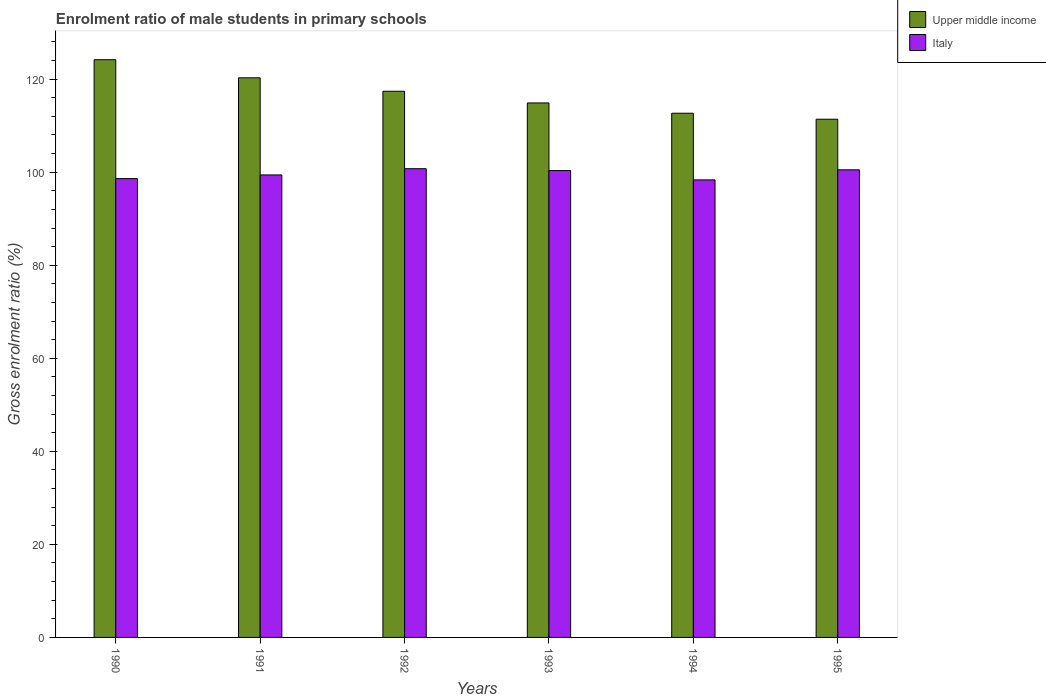How many different coloured bars are there?
Your answer should be very brief. 2. Are the number of bars on each tick of the X-axis equal?
Provide a succinct answer. Yes. How many bars are there on the 6th tick from the left?
Give a very brief answer. 2. What is the enrolment ratio of male students in primary schools in Italy in 1993?
Provide a short and direct response. 100.34. Across all years, what is the maximum enrolment ratio of male students in primary schools in Upper middle income?
Make the answer very short. 124.17. Across all years, what is the minimum enrolment ratio of male students in primary schools in Italy?
Keep it short and to the point. 98.34. In which year was the enrolment ratio of male students in primary schools in Upper middle income maximum?
Ensure brevity in your answer.  1990. What is the total enrolment ratio of male students in primary schools in Italy in the graph?
Provide a short and direct response. 597.97. What is the difference between the enrolment ratio of male students in primary schools in Upper middle income in 1993 and that in 1995?
Offer a very short reply. 3.5. What is the difference between the enrolment ratio of male students in primary schools in Italy in 1992 and the enrolment ratio of male students in primary schools in Upper middle income in 1991?
Your response must be concise. -19.53. What is the average enrolment ratio of male students in primary schools in Italy per year?
Give a very brief answer. 99.66. In the year 1992, what is the difference between the enrolment ratio of male students in primary schools in Italy and enrolment ratio of male students in primary schools in Upper middle income?
Provide a succinct answer. -16.65. In how many years, is the enrolment ratio of male students in primary schools in Upper middle income greater than 120 %?
Your answer should be compact. 2. What is the ratio of the enrolment ratio of male students in primary schools in Upper middle income in 1991 to that in 1994?
Make the answer very short. 1.07. What is the difference between the highest and the second highest enrolment ratio of male students in primary schools in Italy?
Keep it short and to the point. 0.24. What is the difference between the highest and the lowest enrolment ratio of male students in primary schools in Upper middle income?
Make the answer very short. 12.79. In how many years, is the enrolment ratio of male students in primary schools in Upper middle income greater than the average enrolment ratio of male students in primary schools in Upper middle income taken over all years?
Your answer should be very brief. 3. What does the 1st bar from the left in 1995 represents?
Provide a succinct answer. Upper middle income. How many bars are there?
Keep it short and to the point. 12. Are all the bars in the graph horizontal?
Provide a succinct answer. No. How many years are there in the graph?
Provide a short and direct response. 6. What is the difference between two consecutive major ticks on the Y-axis?
Provide a succinct answer. 20. Where does the legend appear in the graph?
Keep it short and to the point. Top right. How are the legend labels stacked?
Provide a short and direct response. Vertical. What is the title of the graph?
Ensure brevity in your answer.  Enrolment ratio of male students in primary schools. Does "Morocco" appear as one of the legend labels in the graph?
Provide a short and direct response. No. What is the label or title of the Y-axis?
Provide a short and direct response. Gross enrolment ratio (%). What is the Gross enrolment ratio (%) in Upper middle income in 1990?
Make the answer very short. 124.17. What is the Gross enrolment ratio (%) of Italy in 1990?
Provide a short and direct response. 98.62. What is the Gross enrolment ratio (%) in Upper middle income in 1991?
Give a very brief answer. 120.28. What is the Gross enrolment ratio (%) of Italy in 1991?
Your answer should be compact. 99.41. What is the Gross enrolment ratio (%) of Upper middle income in 1992?
Your answer should be compact. 117.4. What is the Gross enrolment ratio (%) in Italy in 1992?
Provide a short and direct response. 100.75. What is the Gross enrolment ratio (%) in Upper middle income in 1993?
Give a very brief answer. 114.88. What is the Gross enrolment ratio (%) in Italy in 1993?
Make the answer very short. 100.34. What is the Gross enrolment ratio (%) in Upper middle income in 1994?
Make the answer very short. 112.67. What is the Gross enrolment ratio (%) of Italy in 1994?
Keep it short and to the point. 98.34. What is the Gross enrolment ratio (%) of Upper middle income in 1995?
Your answer should be very brief. 111.38. What is the Gross enrolment ratio (%) in Italy in 1995?
Offer a terse response. 100.51. Across all years, what is the maximum Gross enrolment ratio (%) in Upper middle income?
Offer a very short reply. 124.17. Across all years, what is the maximum Gross enrolment ratio (%) in Italy?
Give a very brief answer. 100.75. Across all years, what is the minimum Gross enrolment ratio (%) in Upper middle income?
Your answer should be compact. 111.38. Across all years, what is the minimum Gross enrolment ratio (%) in Italy?
Your response must be concise. 98.34. What is the total Gross enrolment ratio (%) of Upper middle income in the graph?
Your response must be concise. 700.78. What is the total Gross enrolment ratio (%) of Italy in the graph?
Your answer should be very brief. 597.97. What is the difference between the Gross enrolment ratio (%) of Upper middle income in 1990 and that in 1991?
Your answer should be compact. 3.89. What is the difference between the Gross enrolment ratio (%) in Italy in 1990 and that in 1991?
Provide a succinct answer. -0.79. What is the difference between the Gross enrolment ratio (%) of Upper middle income in 1990 and that in 1992?
Your response must be concise. 6.78. What is the difference between the Gross enrolment ratio (%) in Italy in 1990 and that in 1992?
Offer a very short reply. -2.13. What is the difference between the Gross enrolment ratio (%) of Upper middle income in 1990 and that in 1993?
Offer a very short reply. 9.29. What is the difference between the Gross enrolment ratio (%) in Italy in 1990 and that in 1993?
Provide a succinct answer. -1.72. What is the difference between the Gross enrolment ratio (%) in Upper middle income in 1990 and that in 1994?
Make the answer very short. 11.5. What is the difference between the Gross enrolment ratio (%) in Italy in 1990 and that in 1994?
Your response must be concise. 0.28. What is the difference between the Gross enrolment ratio (%) of Upper middle income in 1990 and that in 1995?
Offer a terse response. 12.79. What is the difference between the Gross enrolment ratio (%) of Italy in 1990 and that in 1995?
Your response must be concise. -1.89. What is the difference between the Gross enrolment ratio (%) in Upper middle income in 1991 and that in 1992?
Keep it short and to the point. 2.88. What is the difference between the Gross enrolment ratio (%) of Italy in 1991 and that in 1992?
Your answer should be very brief. -1.34. What is the difference between the Gross enrolment ratio (%) in Upper middle income in 1991 and that in 1993?
Your response must be concise. 5.4. What is the difference between the Gross enrolment ratio (%) in Italy in 1991 and that in 1993?
Make the answer very short. -0.94. What is the difference between the Gross enrolment ratio (%) of Upper middle income in 1991 and that in 1994?
Provide a succinct answer. 7.61. What is the difference between the Gross enrolment ratio (%) of Italy in 1991 and that in 1994?
Provide a short and direct response. 1.07. What is the difference between the Gross enrolment ratio (%) of Upper middle income in 1991 and that in 1995?
Give a very brief answer. 8.9. What is the difference between the Gross enrolment ratio (%) in Italy in 1991 and that in 1995?
Provide a succinct answer. -1.1. What is the difference between the Gross enrolment ratio (%) of Upper middle income in 1992 and that in 1993?
Ensure brevity in your answer.  2.51. What is the difference between the Gross enrolment ratio (%) in Italy in 1992 and that in 1993?
Your answer should be compact. 0.41. What is the difference between the Gross enrolment ratio (%) in Upper middle income in 1992 and that in 1994?
Make the answer very short. 4.73. What is the difference between the Gross enrolment ratio (%) in Italy in 1992 and that in 1994?
Give a very brief answer. 2.41. What is the difference between the Gross enrolment ratio (%) in Upper middle income in 1992 and that in 1995?
Make the answer very short. 6.02. What is the difference between the Gross enrolment ratio (%) in Italy in 1992 and that in 1995?
Your response must be concise. 0.24. What is the difference between the Gross enrolment ratio (%) of Upper middle income in 1993 and that in 1994?
Give a very brief answer. 2.21. What is the difference between the Gross enrolment ratio (%) of Italy in 1993 and that in 1994?
Give a very brief answer. 2. What is the difference between the Gross enrolment ratio (%) of Upper middle income in 1993 and that in 1995?
Provide a short and direct response. 3.5. What is the difference between the Gross enrolment ratio (%) in Italy in 1993 and that in 1995?
Ensure brevity in your answer.  -0.16. What is the difference between the Gross enrolment ratio (%) of Upper middle income in 1994 and that in 1995?
Make the answer very short. 1.29. What is the difference between the Gross enrolment ratio (%) in Italy in 1994 and that in 1995?
Offer a very short reply. -2.16. What is the difference between the Gross enrolment ratio (%) of Upper middle income in 1990 and the Gross enrolment ratio (%) of Italy in 1991?
Your response must be concise. 24.76. What is the difference between the Gross enrolment ratio (%) of Upper middle income in 1990 and the Gross enrolment ratio (%) of Italy in 1992?
Offer a very short reply. 23.42. What is the difference between the Gross enrolment ratio (%) in Upper middle income in 1990 and the Gross enrolment ratio (%) in Italy in 1993?
Provide a succinct answer. 23.83. What is the difference between the Gross enrolment ratio (%) in Upper middle income in 1990 and the Gross enrolment ratio (%) in Italy in 1994?
Your answer should be compact. 25.83. What is the difference between the Gross enrolment ratio (%) of Upper middle income in 1990 and the Gross enrolment ratio (%) of Italy in 1995?
Your answer should be very brief. 23.67. What is the difference between the Gross enrolment ratio (%) of Upper middle income in 1991 and the Gross enrolment ratio (%) of Italy in 1992?
Your answer should be compact. 19.53. What is the difference between the Gross enrolment ratio (%) in Upper middle income in 1991 and the Gross enrolment ratio (%) in Italy in 1993?
Provide a succinct answer. 19.94. What is the difference between the Gross enrolment ratio (%) in Upper middle income in 1991 and the Gross enrolment ratio (%) in Italy in 1994?
Offer a terse response. 21.94. What is the difference between the Gross enrolment ratio (%) in Upper middle income in 1991 and the Gross enrolment ratio (%) in Italy in 1995?
Provide a short and direct response. 19.77. What is the difference between the Gross enrolment ratio (%) in Upper middle income in 1992 and the Gross enrolment ratio (%) in Italy in 1993?
Keep it short and to the point. 17.05. What is the difference between the Gross enrolment ratio (%) of Upper middle income in 1992 and the Gross enrolment ratio (%) of Italy in 1994?
Your answer should be compact. 19.05. What is the difference between the Gross enrolment ratio (%) in Upper middle income in 1992 and the Gross enrolment ratio (%) in Italy in 1995?
Offer a very short reply. 16.89. What is the difference between the Gross enrolment ratio (%) of Upper middle income in 1993 and the Gross enrolment ratio (%) of Italy in 1994?
Make the answer very short. 16.54. What is the difference between the Gross enrolment ratio (%) of Upper middle income in 1993 and the Gross enrolment ratio (%) of Italy in 1995?
Give a very brief answer. 14.37. What is the difference between the Gross enrolment ratio (%) of Upper middle income in 1994 and the Gross enrolment ratio (%) of Italy in 1995?
Offer a terse response. 12.16. What is the average Gross enrolment ratio (%) in Upper middle income per year?
Your answer should be very brief. 116.8. What is the average Gross enrolment ratio (%) of Italy per year?
Make the answer very short. 99.66. In the year 1990, what is the difference between the Gross enrolment ratio (%) of Upper middle income and Gross enrolment ratio (%) of Italy?
Offer a very short reply. 25.55. In the year 1991, what is the difference between the Gross enrolment ratio (%) in Upper middle income and Gross enrolment ratio (%) in Italy?
Your response must be concise. 20.87. In the year 1992, what is the difference between the Gross enrolment ratio (%) of Upper middle income and Gross enrolment ratio (%) of Italy?
Ensure brevity in your answer.  16.65. In the year 1993, what is the difference between the Gross enrolment ratio (%) in Upper middle income and Gross enrolment ratio (%) in Italy?
Make the answer very short. 14.54. In the year 1994, what is the difference between the Gross enrolment ratio (%) of Upper middle income and Gross enrolment ratio (%) of Italy?
Your answer should be compact. 14.33. In the year 1995, what is the difference between the Gross enrolment ratio (%) in Upper middle income and Gross enrolment ratio (%) in Italy?
Offer a terse response. 10.87. What is the ratio of the Gross enrolment ratio (%) in Upper middle income in 1990 to that in 1991?
Your response must be concise. 1.03. What is the ratio of the Gross enrolment ratio (%) of Upper middle income in 1990 to that in 1992?
Your answer should be very brief. 1.06. What is the ratio of the Gross enrolment ratio (%) in Italy in 1990 to that in 1992?
Provide a short and direct response. 0.98. What is the ratio of the Gross enrolment ratio (%) of Upper middle income in 1990 to that in 1993?
Give a very brief answer. 1.08. What is the ratio of the Gross enrolment ratio (%) of Italy in 1990 to that in 1993?
Your answer should be compact. 0.98. What is the ratio of the Gross enrolment ratio (%) of Upper middle income in 1990 to that in 1994?
Your response must be concise. 1.1. What is the ratio of the Gross enrolment ratio (%) of Upper middle income in 1990 to that in 1995?
Your answer should be compact. 1.11. What is the ratio of the Gross enrolment ratio (%) of Italy in 1990 to that in 1995?
Ensure brevity in your answer.  0.98. What is the ratio of the Gross enrolment ratio (%) in Upper middle income in 1991 to that in 1992?
Give a very brief answer. 1.02. What is the ratio of the Gross enrolment ratio (%) in Italy in 1991 to that in 1992?
Your answer should be very brief. 0.99. What is the ratio of the Gross enrolment ratio (%) of Upper middle income in 1991 to that in 1993?
Ensure brevity in your answer.  1.05. What is the ratio of the Gross enrolment ratio (%) in Italy in 1991 to that in 1993?
Your response must be concise. 0.99. What is the ratio of the Gross enrolment ratio (%) of Upper middle income in 1991 to that in 1994?
Keep it short and to the point. 1.07. What is the ratio of the Gross enrolment ratio (%) in Italy in 1991 to that in 1994?
Your answer should be compact. 1.01. What is the ratio of the Gross enrolment ratio (%) in Upper middle income in 1991 to that in 1995?
Make the answer very short. 1.08. What is the ratio of the Gross enrolment ratio (%) in Upper middle income in 1992 to that in 1993?
Your response must be concise. 1.02. What is the ratio of the Gross enrolment ratio (%) in Italy in 1992 to that in 1993?
Offer a terse response. 1. What is the ratio of the Gross enrolment ratio (%) in Upper middle income in 1992 to that in 1994?
Your answer should be very brief. 1.04. What is the ratio of the Gross enrolment ratio (%) of Italy in 1992 to that in 1994?
Keep it short and to the point. 1.02. What is the ratio of the Gross enrolment ratio (%) of Upper middle income in 1992 to that in 1995?
Ensure brevity in your answer.  1.05. What is the ratio of the Gross enrolment ratio (%) of Upper middle income in 1993 to that in 1994?
Offer a terse response. 1.02. What is the ratio of the Gross enrolment ratio (%) of Italy in 1993 to that in 1994?
Give a very brief answer. 1.02. What is the ratio of the Gross enrolment ratio (%) in Upper middle income in 1993 to that in 1995?
Ensure brevity in your answer.  1.03. What is the ratio of the Gross enrolment ratio (%) of Italy in 1993 to that in 1995?
Ensure brevity in your answer.  1. What is the ratio of the Gross enrolment ratio (%) in Upper middle income in 1994 to that in 1995?
Your response must be concise. 1.01. What is the ratio of the Gross enrolment ratio (%) of Italy in 1994 to that in 1995?
Provide a short and direct response. 0.98. What is the difference between the highest and the second highest Gross enrolment ratio (%) in Upper middle income?
Provide a short and direct response. 3.89. What is the difference between the highest and the second highest Gross enrolment ratio (%) of Italy?
Your answer should be compact. 0.24. What is the difference between the highest and the lowest Gross enrolment ratio (%) of Upper middle income?
Make the answer very short. 12.79. What is the difference between the highest and the lowest Gross enrolment ratio (%) in Italy?
Make the answer very short. 2.41. 